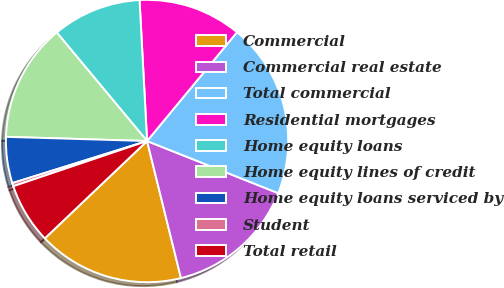<chart> <loc_0><loc_0><loc_500><loc_500><pie_chart><fcel>Commercial<fcel>Commercial real estate<fcel>Total commercial<fcel>Residential mortgages<fcel>Home equity loans<fcel>Home equity lines of credit<fcel>Home equity loans serviced by<fcel>Student<fcel>Total retail<nl><fcel>16.75%<fcel>15.12%<fcel>20.03%<fcel>11.84%<fcel>10.2%<fcel>13.48%<fcel>5.29%<fcel>0.37%<fcel>6.92%<nl></chart> 